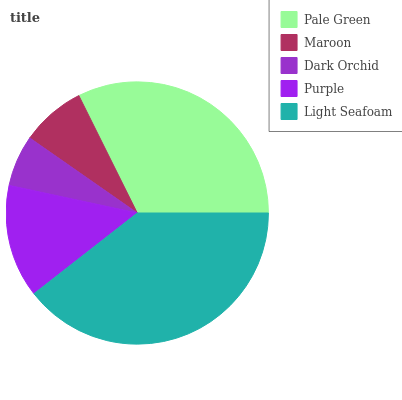Is Dark Orchid the minimum?
Answer yes or no. Yes. Is Light Seafoam the maximum?
Answer yes or no. Yes. Is Maroon the minimum?
Answer yes or no. No. Is Maroon the maximum?
Answer yes or no. No. Is Pale Green greater than Maroon?
Answer yes or no. Yes. Is Maroon less than Pale Green?
Answer yes or no. Yes. Is Maroon greater than Pale Green?
Answer yes or no. No. Is Pale Green less than Maroon?
Answer yes or no. No. Is Purple the high median?
Answer yes or no. Yes. Is Purple the low median?
Answer yes or no. Yes. Is Dark Orchid the high median?
Answer yes or no. No. Is Light Seafoam the low median?
Answer yes or no. No. 